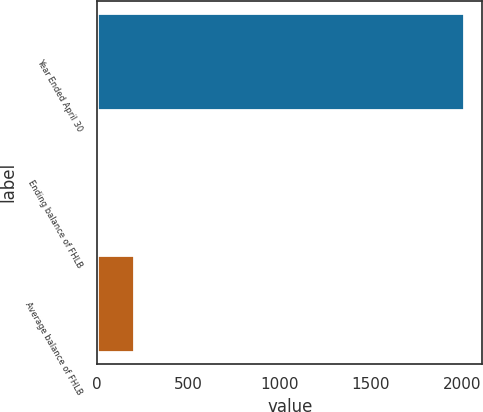Convert chart to OTSL. <chart><loc_0><loc_0><loc_500><loc_500><bar_chart><fcel>Year Ended April 30<fcel>Ending balance of FHLB<fcel>Average balance of FHLB<nl><fcel>2010<fcel>1.92<fcel>202.73<nl></chart> 